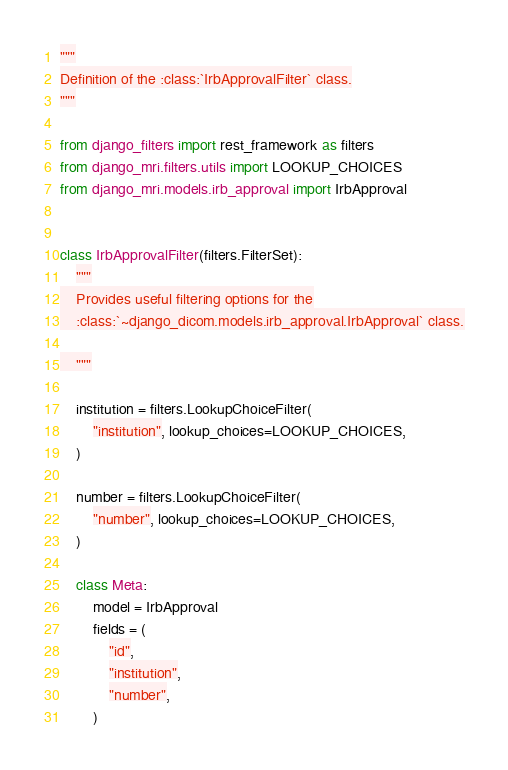<code> <loc_0><loc_0><loc_500><loc_500><_Python_>"""
Definition of the :class:`IrbApprovalFilter` class.
"""

from django_filters import rest_framework as filters
from django_mri.filters.utils import LOOKUP_CHOICES
from django_mri.models.irb_approval import IrbApproval


class IrbApprovalFilter(filters.FilterSet):
    """
    Provides useful filtering options for the
    :class:`~django_dicom.models.irb_approval.IrbApproval` class.

    """

    institution = filters.LookupChoiceFilter(
        "institution", lookup_choices=LOOKUP_CHOICES,
    )

    number = filters.LookupChoiceFilter(
        "number", lookup_choices=LOOKUP_CHOICES,
    )

    class Meta:
        model = IrbApproval
        fields = (
            "id",
            "institution",
            "number",
        )
</code> 